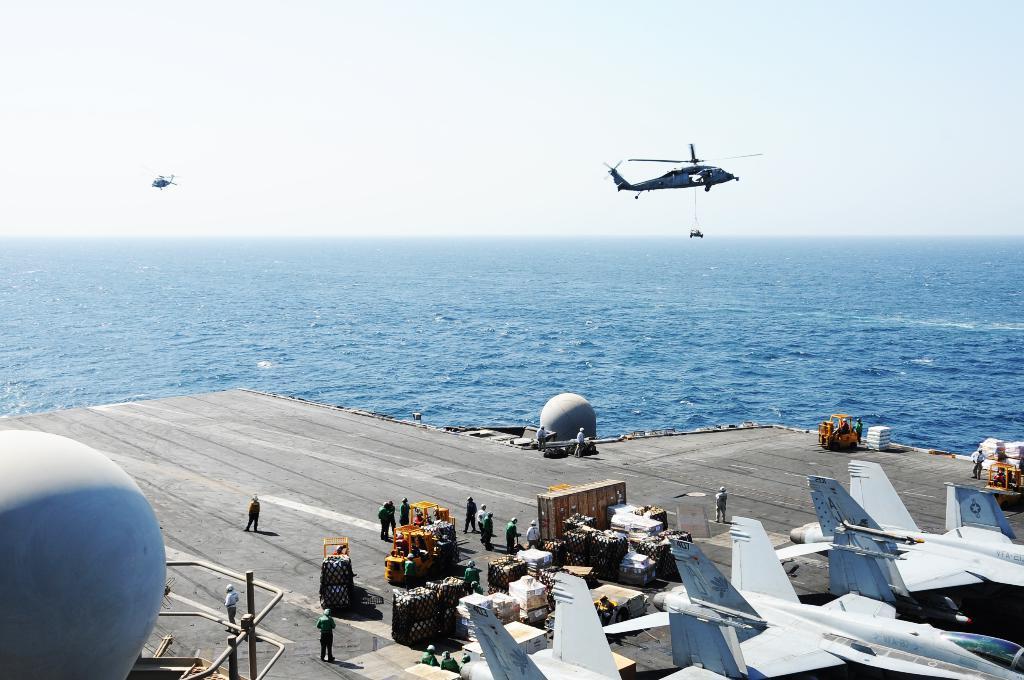Please provide a concise description of this image. In this image we can see the airplanes, vehicles, cardboard boxes and also some luggages. We can also see the people standing on the runway. Image also consists of two circular structures. In the background we can see the sea and also the sky. 